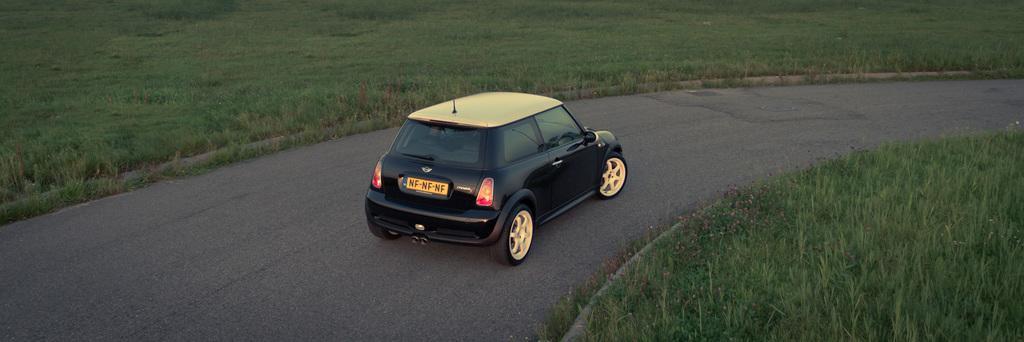How would you summarize this image in a sentence or two? In this image I can see car on the road, beside that there is a grass. 